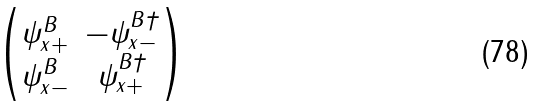Convert formula to latex. <formula><loc_0><loc_0><loc_500><loc_500>\begin{pmatrix} \psi _ { x + } ^ { B } & - \psi _ { x - } ^ { B \dagger } \\ \psi _ { x - } ^ { B } & \psi _ { x + } ^ { B \dagger } \end{pmatrix}</formula> 